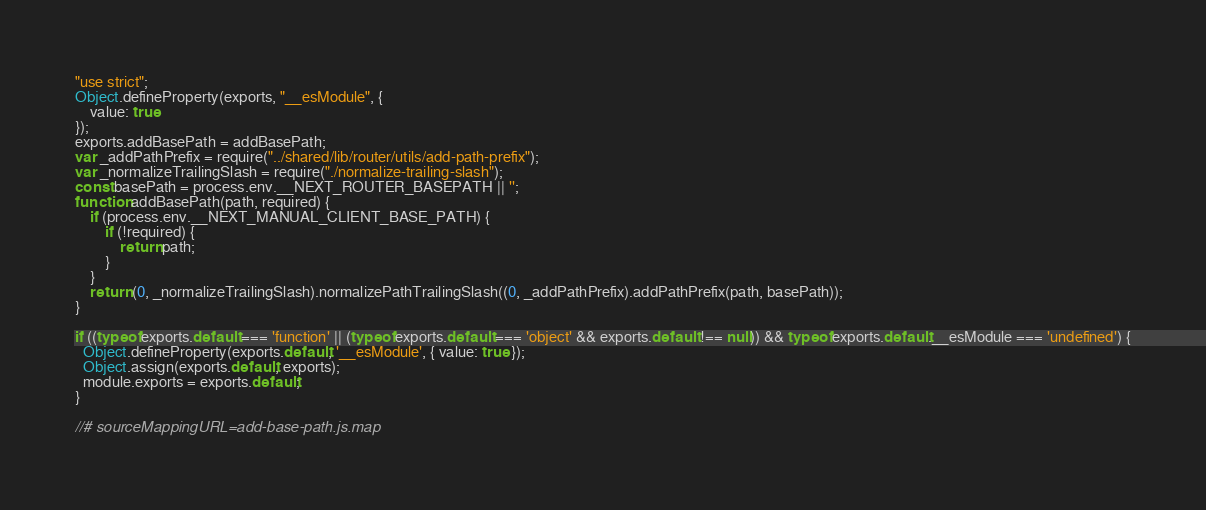Convert code to text. <code><loc_0><loc_0><loc_500><loc_500><_JavaScript_>"use strict";
Object.defineProperty(exports, "__esModule", {
    value: true
});
exports.addBasePath = addBasePath;
var _addPathPrefix = require("../shared/lib/router/utils/add-path-prefix");
var _normalizeTrailingSlash = require("./normalize-trailing-slash");
const basePath = process.env.__NEXT_ROUTER_BASEPATH || '';
function addBasePath(path, required) {
    if (process.env.__NEXT_MANUAL_CLIENT_BASE_PATH) {
        if (!required) {
            return path;
        }
    }
    return (0, _normalizeTrailingSlash).normalizePathTrailingSlash((0, _addPathPrefix).addPathPrefix(path, basePath));
}

if ((typeof exports.default === 'function' || (typeof exports.default === 'object' && exports.default !== null)) && typeof exports.default.__esModule === 'undefined') {
  Object.defineProperty(exports.default, '__esModule', { value: true });
  Object.assign(exports.default, exports);
  module.exports = exports.default;
}

//# sourceMappingURL=add-base-path.js.map</code> 